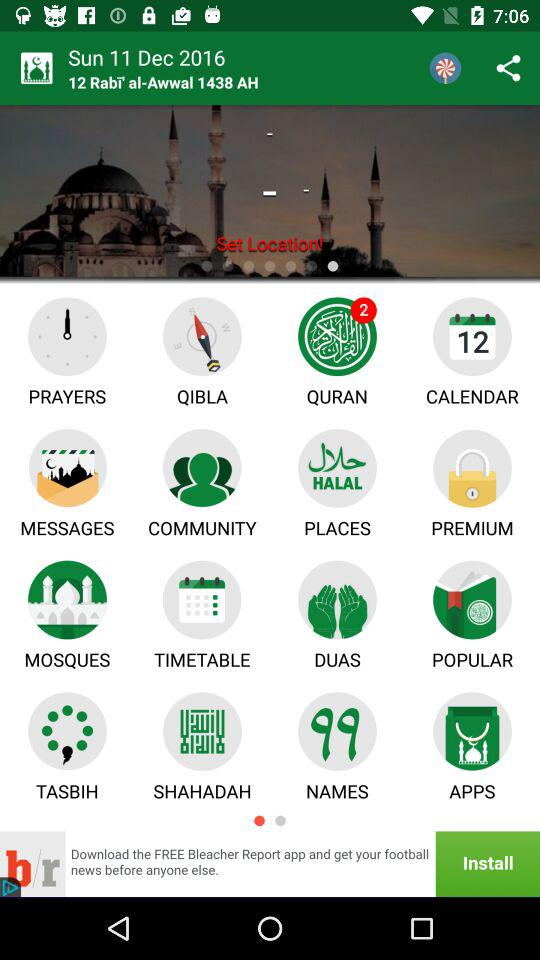How many unread notifications are there for "QURAN"? There are 2 unread notifications for "QURAN". 